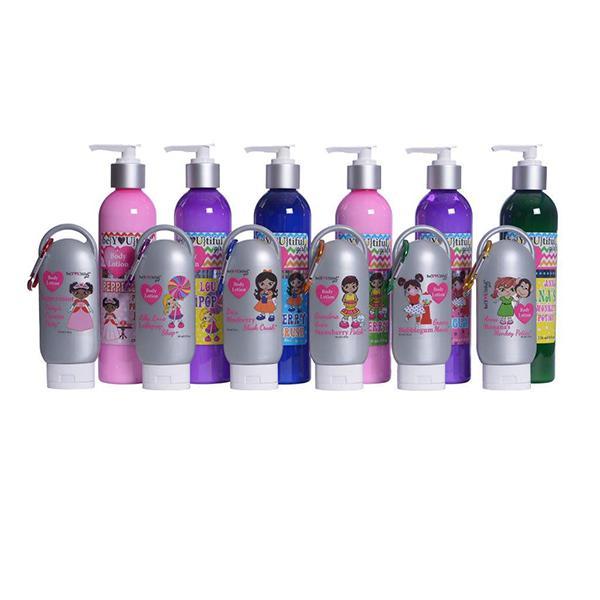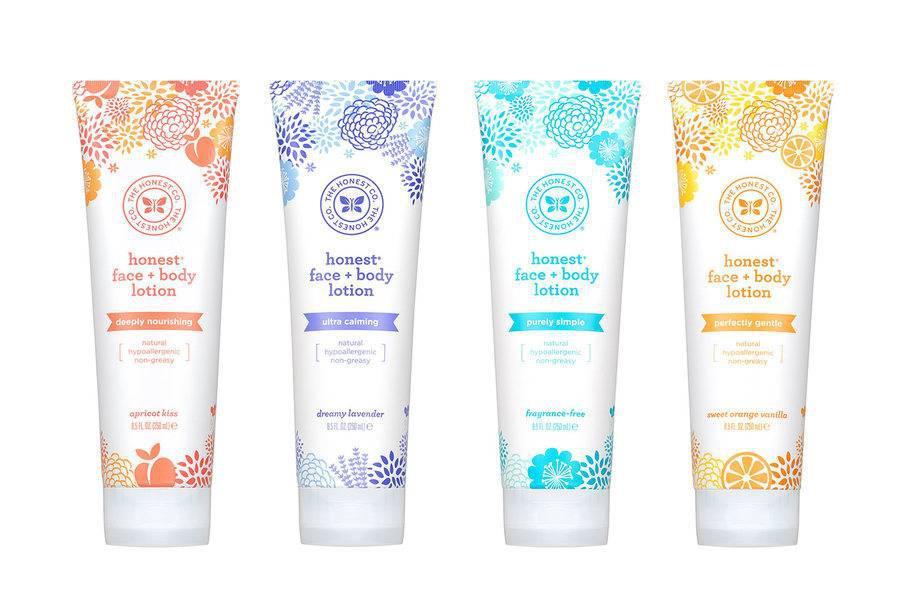The first image is the image on the left, the second image is the image on the right. Considering the images on both sides, is "The lefthand image includes a pump-applicator bottle, while the right image contains at least four versions of one product that doesn't have a pump top." valid? Answer yes or no. Yes. The first image is the image on the left, the second image is the image on the right. Analyze the images presented: Is the assertion "In at least one image there is a total of two wash bottles." valid? Answer yes or no. No. 